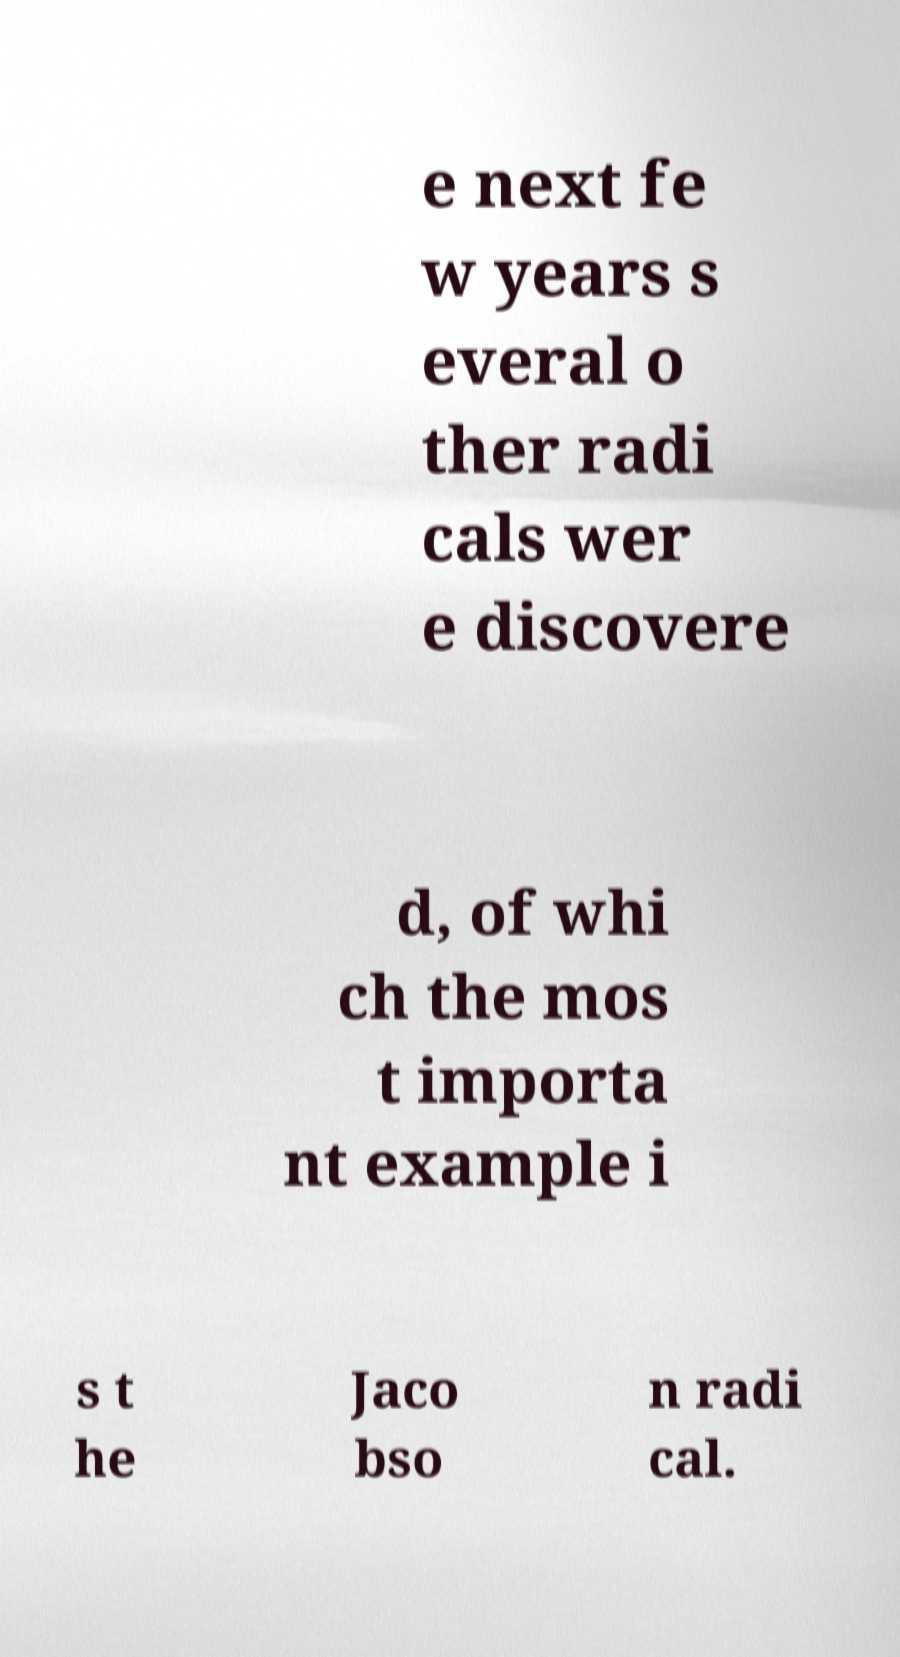Can you read and provide the text displayed in the image?This photo seems to have some interesting text. Can you extract and type it out for me? e next fe w years s everal o ther radi cals wer e discovere d, of whi ch the mos t importa nt example i s t he Jaco bso n radi cal. 